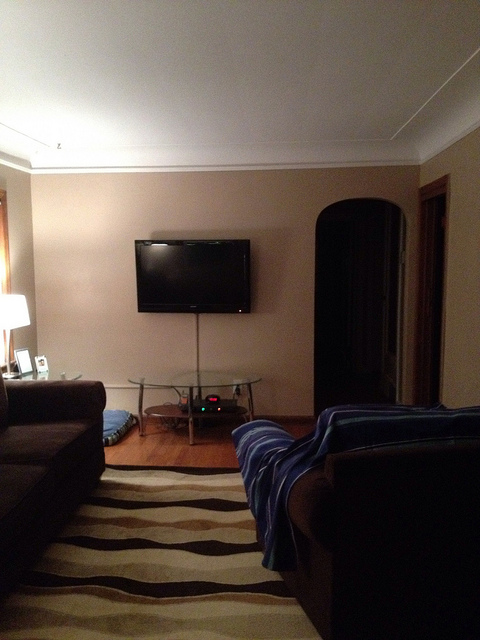<image>What is the style of chair shown on the left? It's unknown what the style of the chair shown on the left is. It could be a couch, sofa, modern, recliner, or overstuffed. What is the style of chair shown on the left? I am not sure what the style of chair is shown on the left. It can be 'couch', 'sofa', 'modern', 'recliner', or 'brown'. 